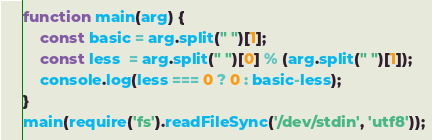<code> <loc_0><loc_0><loc_500><loc_500><_JavaScript_>function main(arg) {
    const basic = arg.split(" ")[1];
    const less  = arg.split(" ")[0] % (arg.split(" ")[1]);
    console.log(less === 0 ? 0 : basic-less);
}
main(require('fs').readFileSync('/dev/stdin', 'utf8'));</code> 